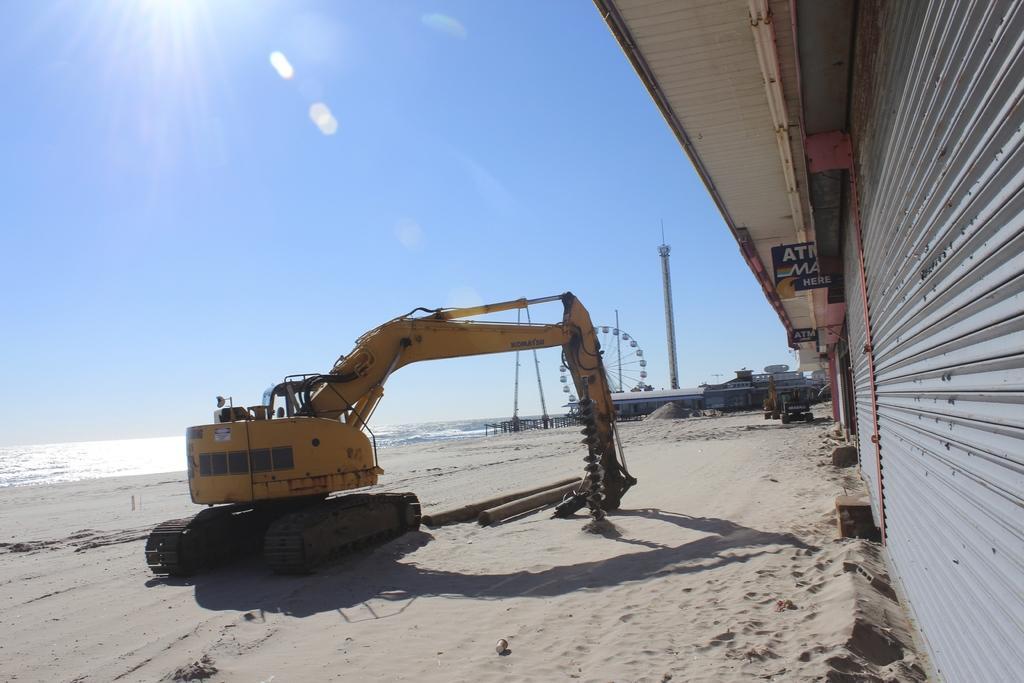Please provide a concise description of this image. In this image we can see an excavator, joint wheel, poles, tower, sheds, boards, and shutters. Here we can see sand and water. In the background there is sky. 